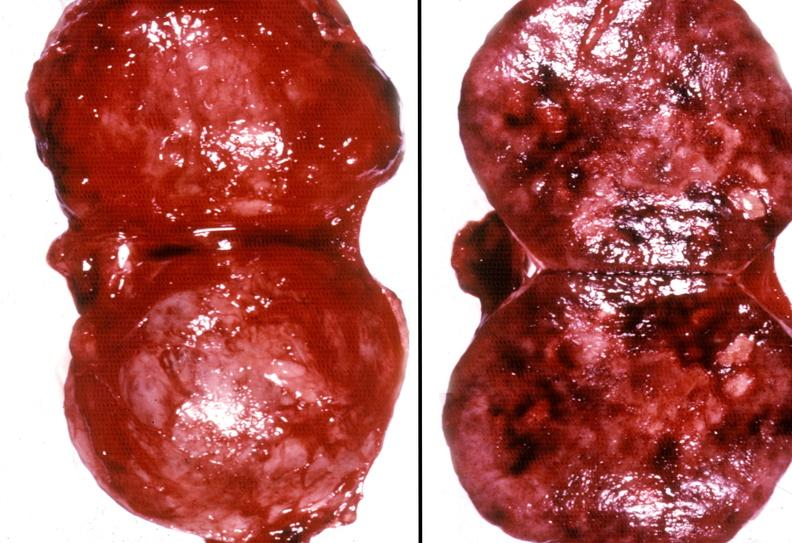does this image show adrenal phaeochromocytoma?
Answer the question using a single word or phrase. Yes 